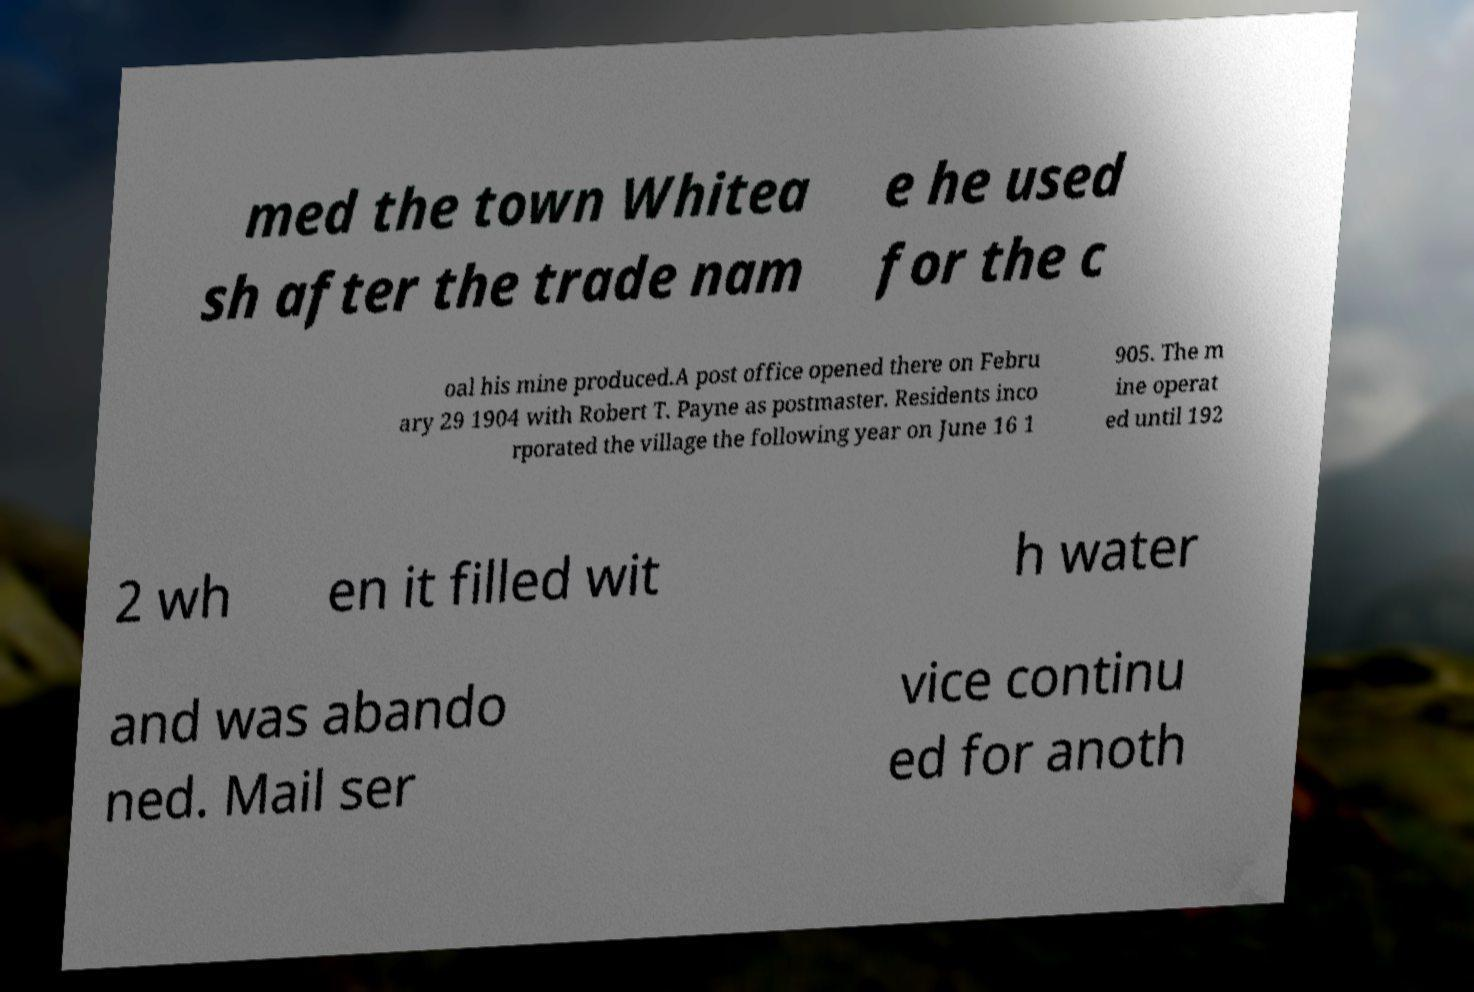Can you read and provide the text displayed in the image?This photo seems to have some interesting text. Can you extract and type it out for me? med the town Whitea sh after the trade nam e he used for the c oal his mine produced.A post office opened there on Febru ary 29 1904 with Robert T. Payne as postmaster. Residents inco rporated the village the following year on June 16 1 905. The m ine operat ed until 192 2 wh en it filled wit h water and was abando ned. Mail ser vice continu ed for anoth 